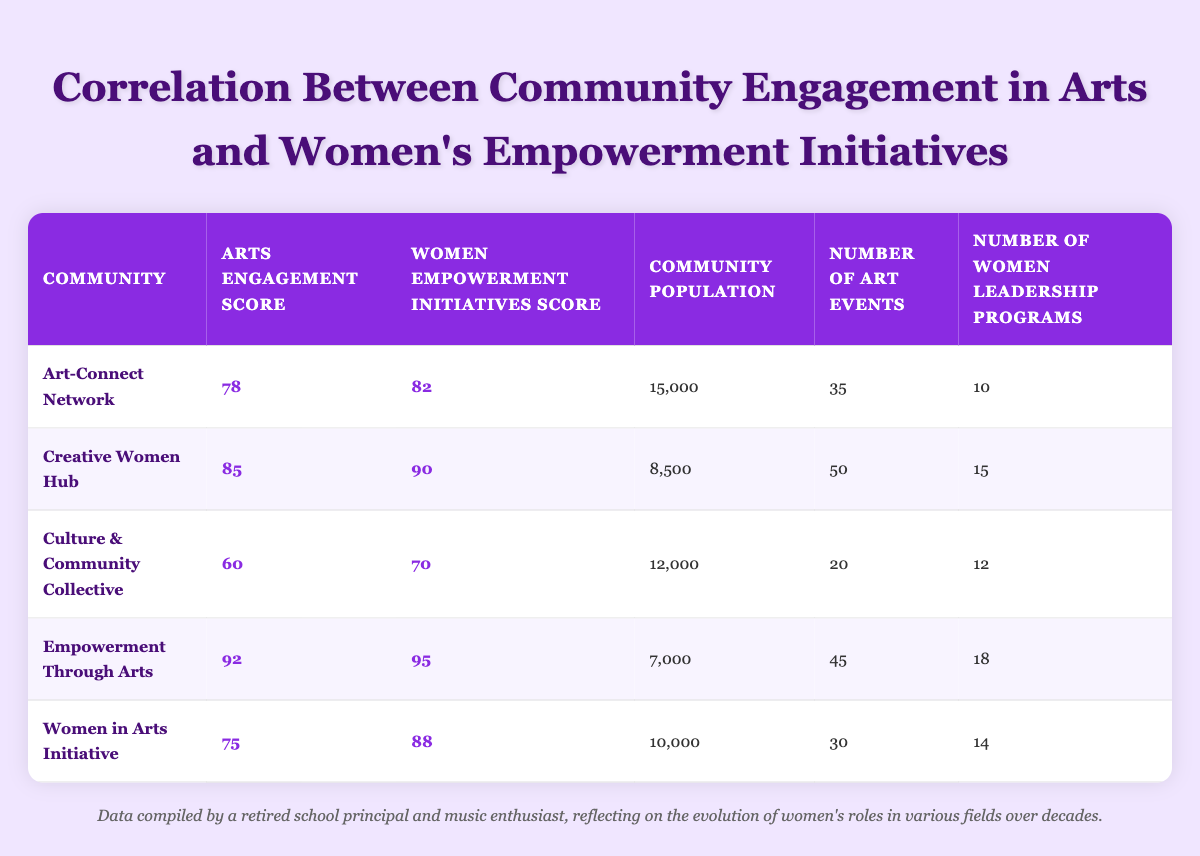What is the arts engagement score for the Empowerment Through Arts community? The table shows that the Empowerment Through Arts community has an arts engagement score of 92.
Answer: 92 What is the highest women's empowerment initiatives score among the communities listed? By looking at the scores, the highest women's empowerment initiatives score is 95, which belongs to the Empowerment Through Arts community.
Answer: 95 How many art events does the Creative Women Hub community host? The table indicates that the Creative Women Hub community hosts 50 art events.
Answer: 50 Is the Culture & Community Collective community's arts engagement score greater than its women's empowerment initiatives score? The arts engagement score for Culture & Community Collective is 60, and the women's empowerment initiatives score is 70. Since 60 is not greater than 70, the statement is false.
Answer: No What is the average number of women leadership programs across all communities? To find the average, we sum the number of women leadership programs: 10 + 15 + 12 + 18 + 14 = 69. There are 5 communities, so the average is 69/5 = 13.8.
Answer: 13.8 What is the difference in scores between the Women in Arts Initiative and the Empowerment Through Arts communities? Women's empowerment initiatives score for Women in Arts Initiative is 88 and for Empowerment Through Arts is 95. The difference is 95 - 88 = 7.
Answer: 7 Which community has the lowest arts engagement score? By comparing the arts engagement scores, the Culture & Community Collective has the lowest score of 60.
Answer: Culture & Community Collective Does the Art-Connect Network have more women leadership programs than the number of art events? Art-Connect Network has 10 women leadership programs and 35 art events. Since 10 is less than 35, the statement is false.
Answer: No 